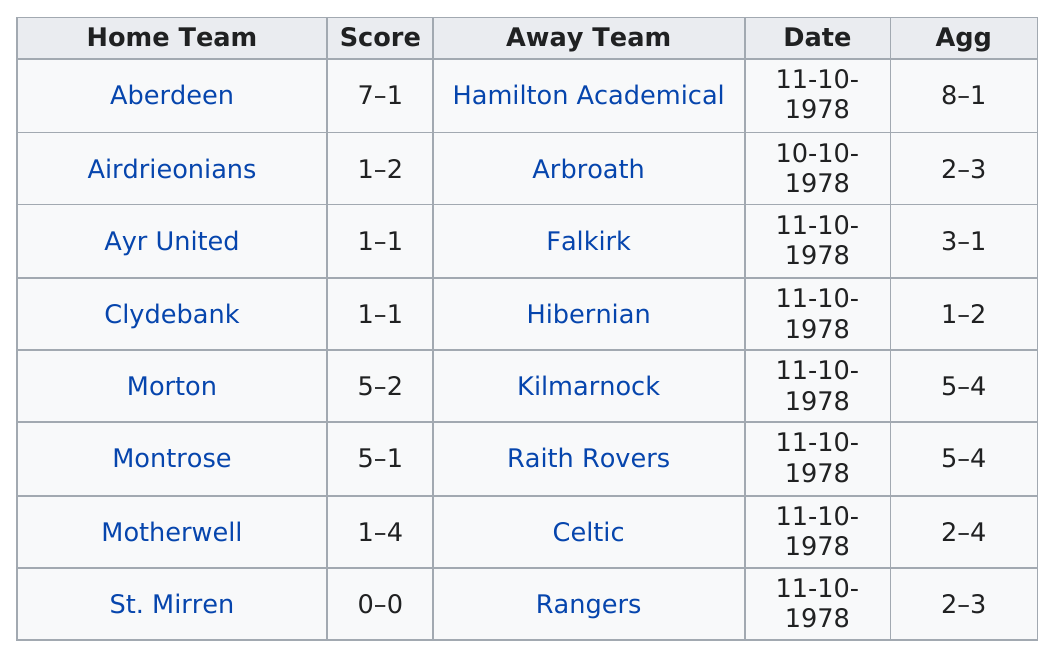Indicate a few pertinent items in this graphic. The Rangers are the away team with the lowest score. Ayr United is currently ranked above Clydebank in the league standings. In the second leg of the match, a total of 33 goals were scored. There are 3 ties listed. Aberdeen has the most points scored among the home teams. 